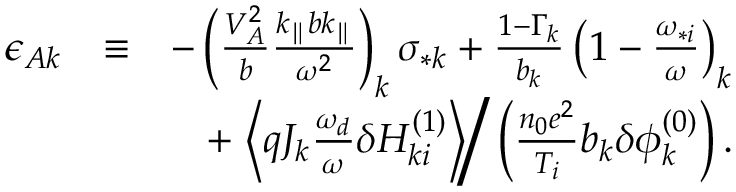<formula> <loc_0><loc_0><loc_500><loc_500>\begin{array} { r l r } { \epsilon _ { A k } } & { \equiv } & { - \left ( \frac { V _ { A } ^ { 2 } } { b } \frac { k _ { \| } b k _ { \| } } { \omega ^ { 2 } } \right ) _ { k } \sigma _ { * k } + \frac { 1 - \Gamma _ { k } } { b _ { k } } \left ( 1 - \frac { \omega _ { * i } } { \omega } \right ) _ { k } } \\ & { + \left \langle q J _ { k } \frac { \omega _ { d } } { \omega } \delta H _ { k i } ^ { ( 1 ) } \right \rangle \right / \left ( \frac { n _ { 0 } e ^ { 2 } } { T _ { i } } b _ { k } \delta \phi _ { k } ^ { ( 0 ) } \right ) . } \end{array}</formula> 